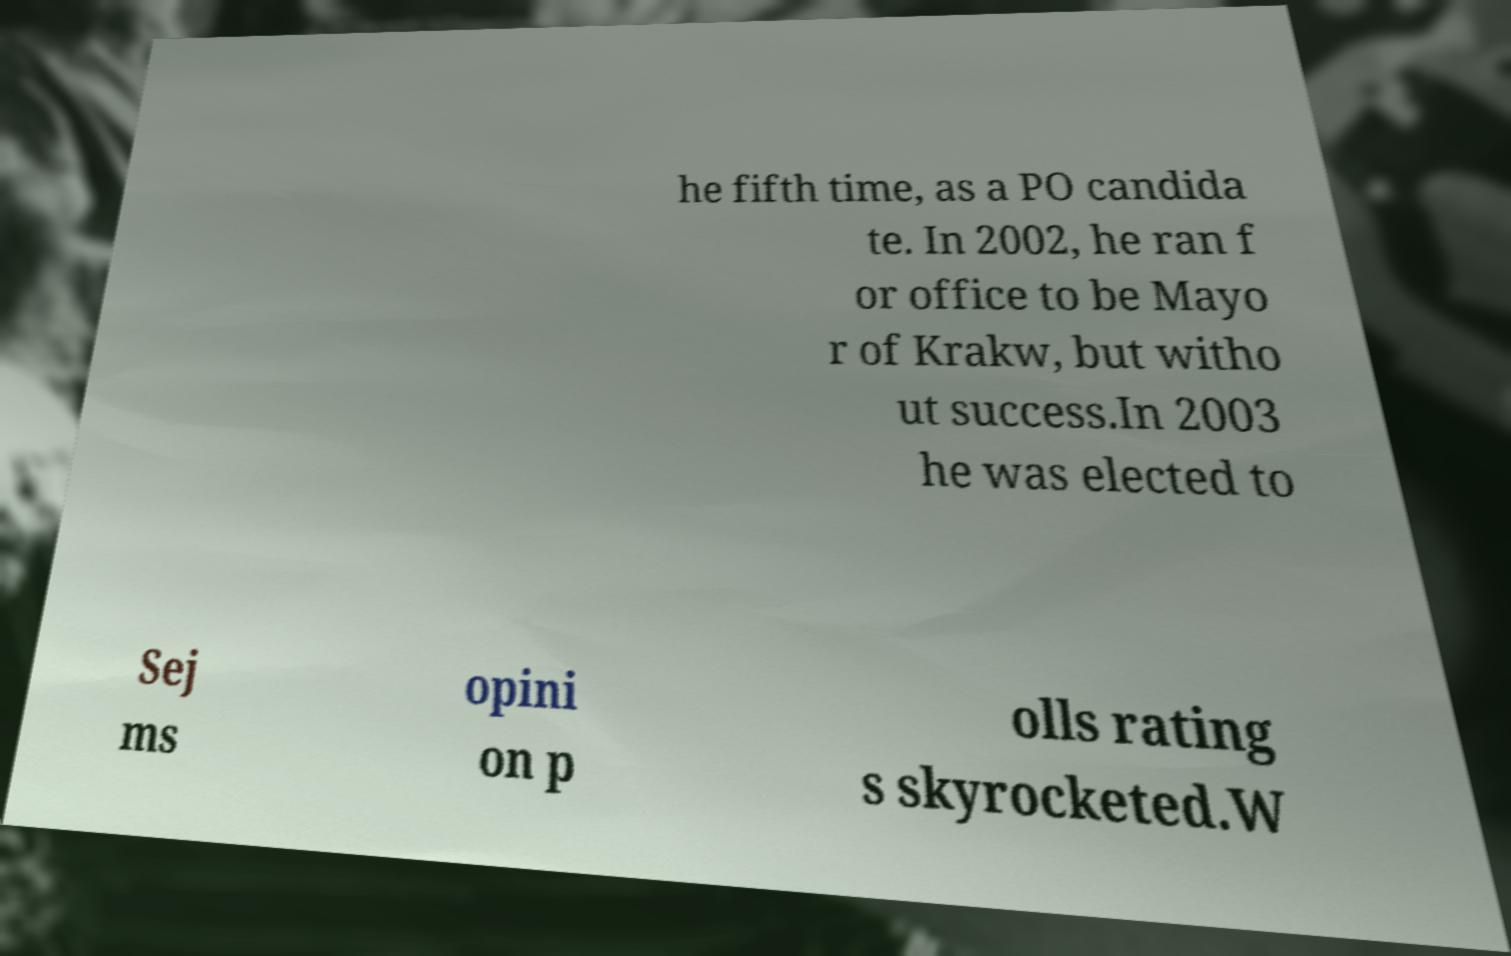For documentation purposes, I need the text within this image transcribed. Could you provide that? he fifth time, as a PO candida te. In 2002, he ran f or office to be Mayo r of Krakw, but witho ut success.In 2003 he was elected to Sej ms opini on p olls rating s skyrocketed.W 